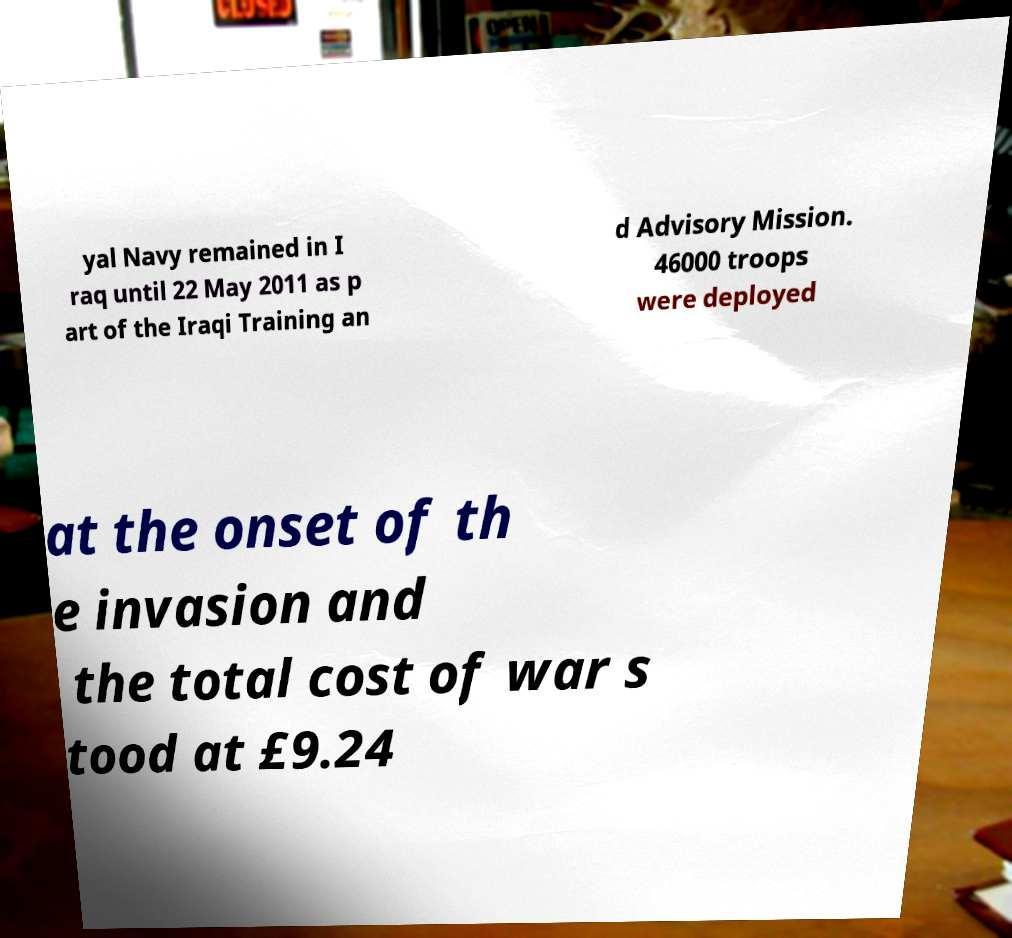Can you read and provide the text displayed in the image?This photo seems to have some interesting text. Can you extract and type it out for me? yal Navy remained in I raq until 22 May 2011 as p art of the Iraqi Training an d Advisory Mission. 46000 troops were deployed at the onset of th e invasion and the total cost of war s tood at £9.24 